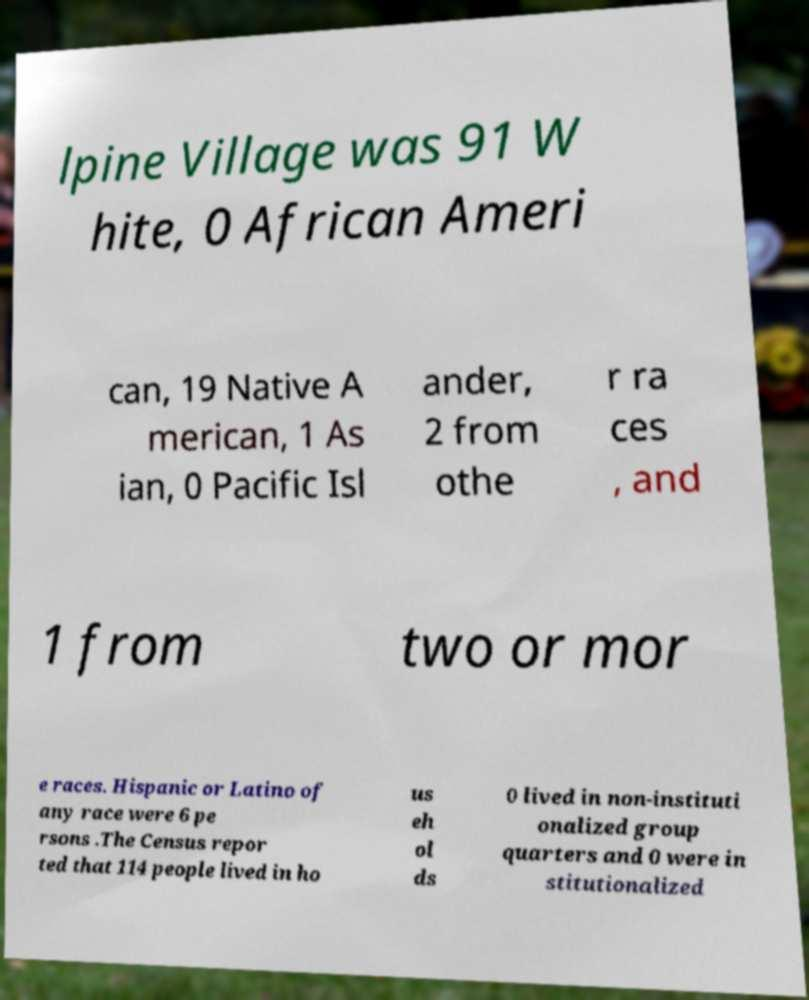For documentation purposes, I need the text within this image transcribed. Could you provide that? lpine Village was 91 W hite, 0 African Ameri can, 19 Native A merican, 1 As ian, 0 Pacific Isl ander, 2 from othe r ra ces , and 1 from two or mor e races. Hispanic or Latino of any race were 6 pe rsons .The Census repor ted that 114 people lived in ho us eh ol ds 0 lived in non-instituti onalized group quarters and 0 were in stitutionalized 